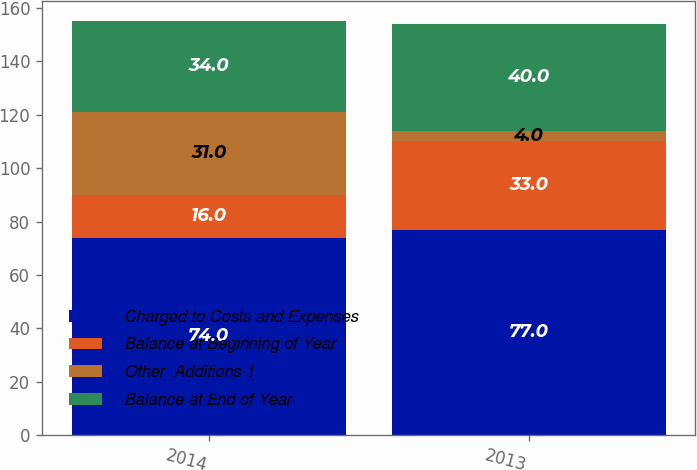Convert chart. <chart><loc_0><loc_0><loc_500><loc_500><stacked_bar_chart><ecel><fcel>2014<fcel>2013<nl><fcel>Charged to Costs and Expenses<fcel>74<fcel>77<nl><fcel>Balance at Beginning of Year<fcel>16<fcel>33<nl><fcel>Other  Additions 1<fcel>31<fcel>4<nl><fcel>Balance at End of Year<fcel>34<fcel>40<nl></chart> 